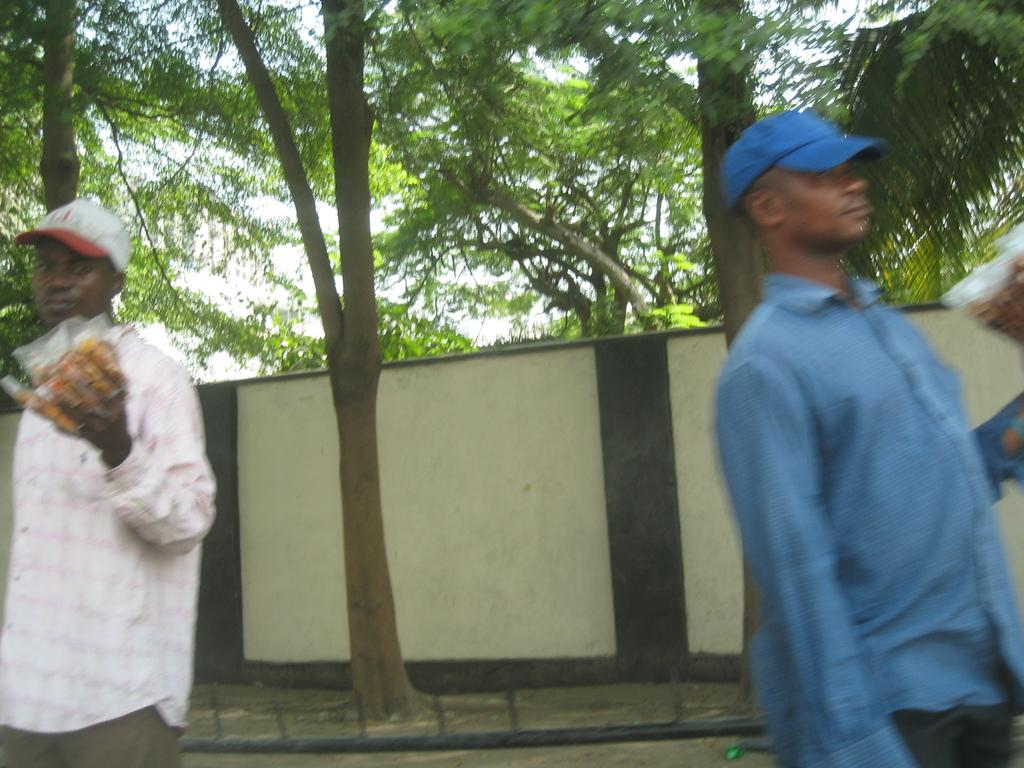How many men are present in the image? There are two men in the image, one on the right side and another on the left side. What is the location of the trees in the image? The trees are at the top side of the image. What is the profit margin of the man on the left side of the image? There is no information about profit margins in the image, as it only shows two men and trees. 